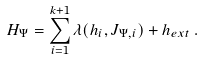<formula> <loc_0><loc_0><loc_500><loc_500>H _ { \Psi } = \sum _ { i = 1 } ^ { k + 1 } \lambda ( h _ { i } , J _ { \Psi , i } ) + h _ { e x t } \, .</formula> 